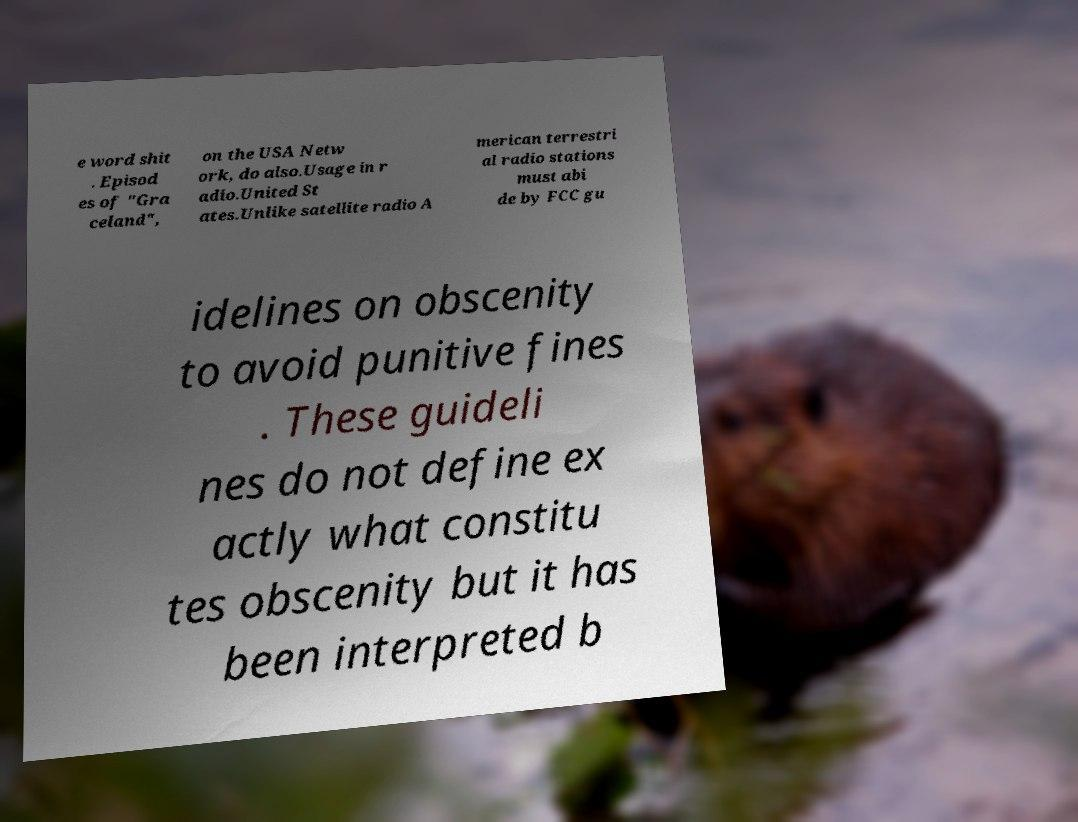What messages or text are displayed in this image? I need them in a readable, typed format. e word shit . Episod es of "Gra celand", on the USA Netw ork, do also.Usage in r adio.United St ates.Unlike satellite radio A merican terrestri al radio stations must abi de by FCC gu idelines on obscenity to avoid punitive fines . These guideli nes do not define ex actly what constitu tes obscenity but it has been interpreted b 